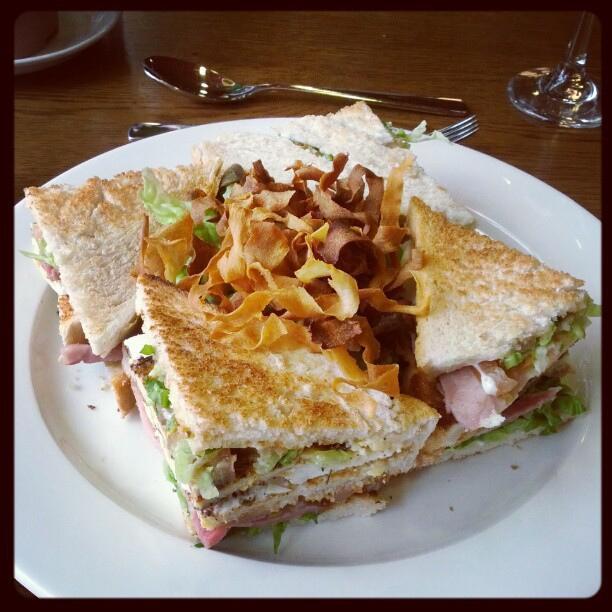How many spoons are there?
Give a very brief answer. 1. How many sandwiches can be seen?
Give a very brief answer. 4. How many dogs are outside?
Give a very brief answer. 0. 